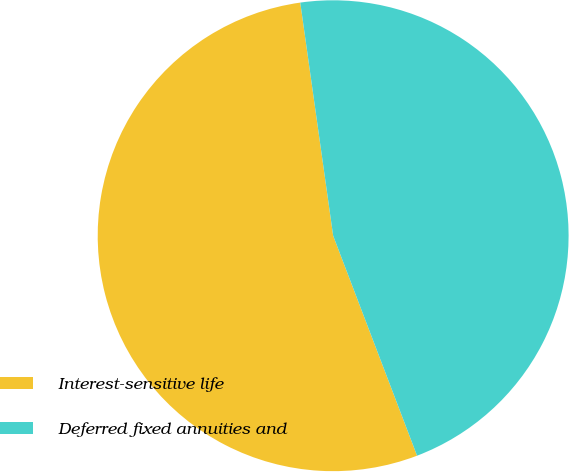Convert chart to OTSL. <chart><loc_0><loc_0><loc_500><loc_500><pie_chart><fcel>Interest-sensitive life<fcel>Deferred fixed annuities and<nl><fcel>53.57%<fcel>46.43%<nl></chart> 